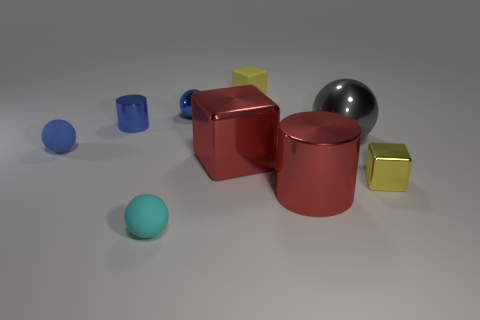How many small blue metallic balls are to the right of the blue object on the right side of the small cyan rubber sphere?
Your answer should be compact. 0. There is a metallic object behind the blue shiny cylinder; is it the same color as the large cylinder that is in front of the small yellow metal cube?
Ensure brevity in your answer.  No. There is a metal object that is to the right of the red cylinder and behind the yellow metal block; what is its shape?
Make the answer very short. Sphere. Are there any small yellow things that have the same shape as the gray metal thing?
Offer a very short reply. No. There is a yellow metallic thing that is the same size as the blue matte ball; what is its shape?
Provide a succinct answer. Cube. What material is the large red block?
Keep it short and to the point. Metal. There is a yellow thing behind the small block that is to the right of the small object that is behind the small metal sphere; what size is it?
Offer a terse response. Small. There is a object that is the same color as the small rubber block; what material is it?
Your answer should be compact. Metal. What number of matte things are either big purple blocks or cylinders?
Your answer should be compact. 0. The blue rubber ball has what size?
Provide a succinct answer. Small. 